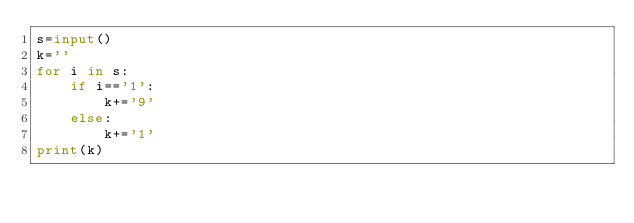<code> <loc_0><loc_0><loc_500><loc_500><_Python_>s=input()
k=''
for i in s:
    if i=='1':
        k+='9'
    else:
        k+='1'
print(k)</code> 